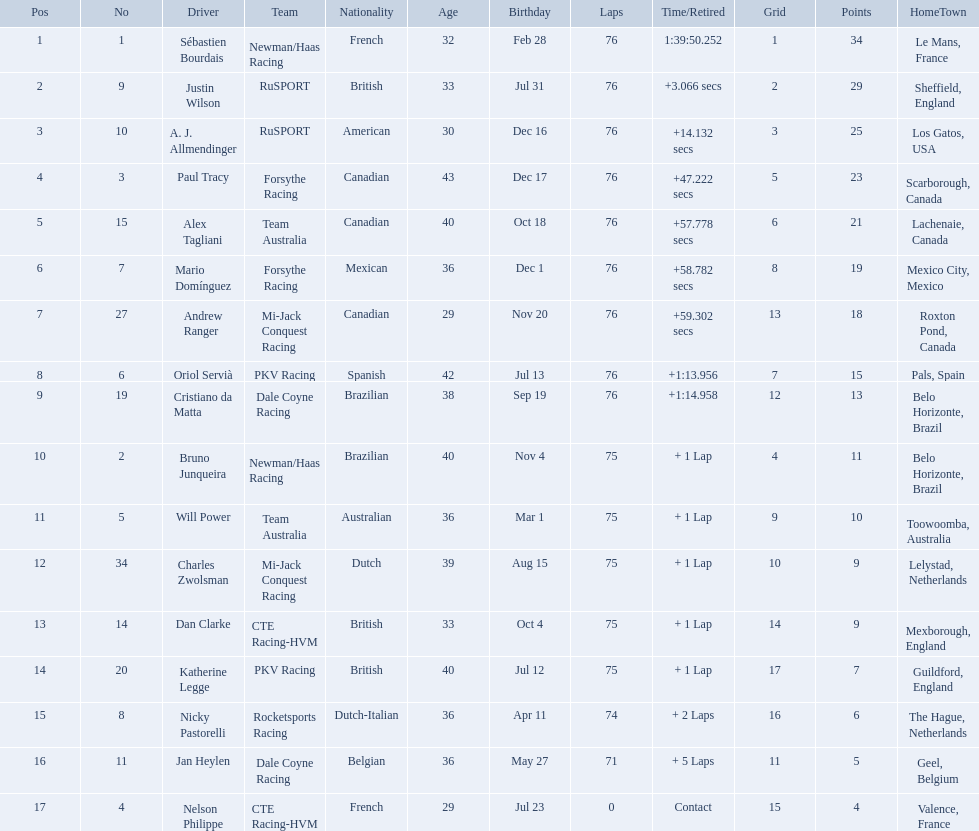Can you give me this table as a dict? {'header': ['Pos', 'No', 'Driver', 'Team', 'Nationality', 'Age', 'Birthday', 'Laps', 'Time/Retired', 'Grid', 'Points', 'HomeTown'], 'rows': [['1', '1', 'Sébastien Bourdais', 'Newman/Haas Racing', 'French', '32', 'Feb 28', '76', '1:39:50.252', '1', '34', 'Le Mans, France'], ['2', '9', 'Justin Wilson', 'RuSPORT', 'British', '33', 'Jul 31', '76', '+3.066 secs', '2', '29', 'Sheffield, England'], ['3', '10', 'A. J. Allmendinger', 'RuSPORT', 'American', '30', 'Dec 16', '76', '+14.132 secs', '3', '25', 'Los Gatos, USA'], ['4', '3', 'Paul Tracy', 'Forsythe Racing', 'Canadian', '43', 'Dec 17', '76', '+47.222 secs', '5', '23', 'Scarborough, Canada'], ['5', '15', 'Alex Tagliani', 'Team Australia', 'Canadian', '40', 'Oct 18', '76', '+57.778 secs', '6', '21', 'Lachenaie, Canada'], ['6', '7', 'Mario Domínguez', 'Forsythe Racing', 'Mexican', '36', 'Dec 1', '76', '+58.782 secs', '8', '19', 'Mexico City, Mexico'], ['7', '27', 'Andrew Ranger', 'Mi-Jack Conquest Racing', 'Canadian', '29', 'Nov 20', '76', '+59.302 secs', '13', '18', 'Roxton Pond, Canada'], ['8', '6', 'Oriol Servià', 'PKV Racing', 'Spanish', '42', 'Jul 13', '76', '+1:13.956', '7', '15', 'Pals, Spain'], ['9', '19', 'Cristiano da Matta', 'Dale Coyne Racing', 'Brazilian', '38', 'Sep 19', '76', '+1:14.958', '12', '13', 'Belo Horizonte, Brazil'], ['10', '2', 'Bruno Junqueira', 'Newman/Haas Racing', 'Brazilian', '40', 'Nov 4', '75', '+ 1 Lap', '4', '11', 'Belo Horizonte, Brazil'], ['11', '5', 'Will Power', 'Team Australia', 'Australian', '36', 'Mar 1', '75', '+ 1 Lap', '9', '10', 'Toowoomba, Australia'], ['12', '34', 'Charles Zwolsman', 'Mi-Jack Conquest Racing', 'Dutch', '39', 'Aug 15', '75', '+ 1 Lap', '10', '9', 'Lelystad, Netherlands'], ['13', '14', 'Dan Clarke', 'CTE Racing-HVM', 'British', '33', 'Oct 4', '75', '+ 1 Lap', '14', '9', 'Mexborough, England'], ['14', '20', 'Katherine Legge', 'PKV Racing', 'British', '40', 'Jul 12', '75', '+ 1 Lap', '17', '7', 'Guildford, England'], ['15', '8', 'Nicky Pastorelli', 'Rocketsports Racing', 'Dutch-Italian', '36', 'Apr 11', '74', '+ 2 Laps', '16', '6', 'The Hague, Netherlands'], ['16', '11', 'Jan Heylen', 'Dale Coyne Racing', 'Belgian', '36', 'May 27', '71', '+ 5 Laps', '11', '5', 'Geel, Belgium'], ['17', '4', 'Nelson Philippe', 'CTE Racing-HVM', 'French', '29', 'Jul 23', '0', 'Contact', '15', '4', 'Valence, France']]} What drivers took part in the 2006 tecate grand prix of monterrey? Sébastien Bourdais, Justin Wilson, A. J. Allmendinger, Paul Tracy, Alex Tagliani, Mario Domínguez, Andrew Ranger, Oriol Servià, Cristiano da Matta, Bruno Junqueira, Will Power, Charles Zwolsman, Dan Clarke, Katherine Legge, Nicky Pastorelli, Jan Heylen, Nelson Philippe. Which of those drivers scored the same amount of points as another driver? Charles Zwolsman, Dan Clarke. Who had the same amount of points as charles zwolsman? Dan Clarke. What was alex taglini's final score in the tecate grand prix? 21. What was paul tracy's final score in the tecate grand prix? 23. Which driver finished first? Paul Tracy. 